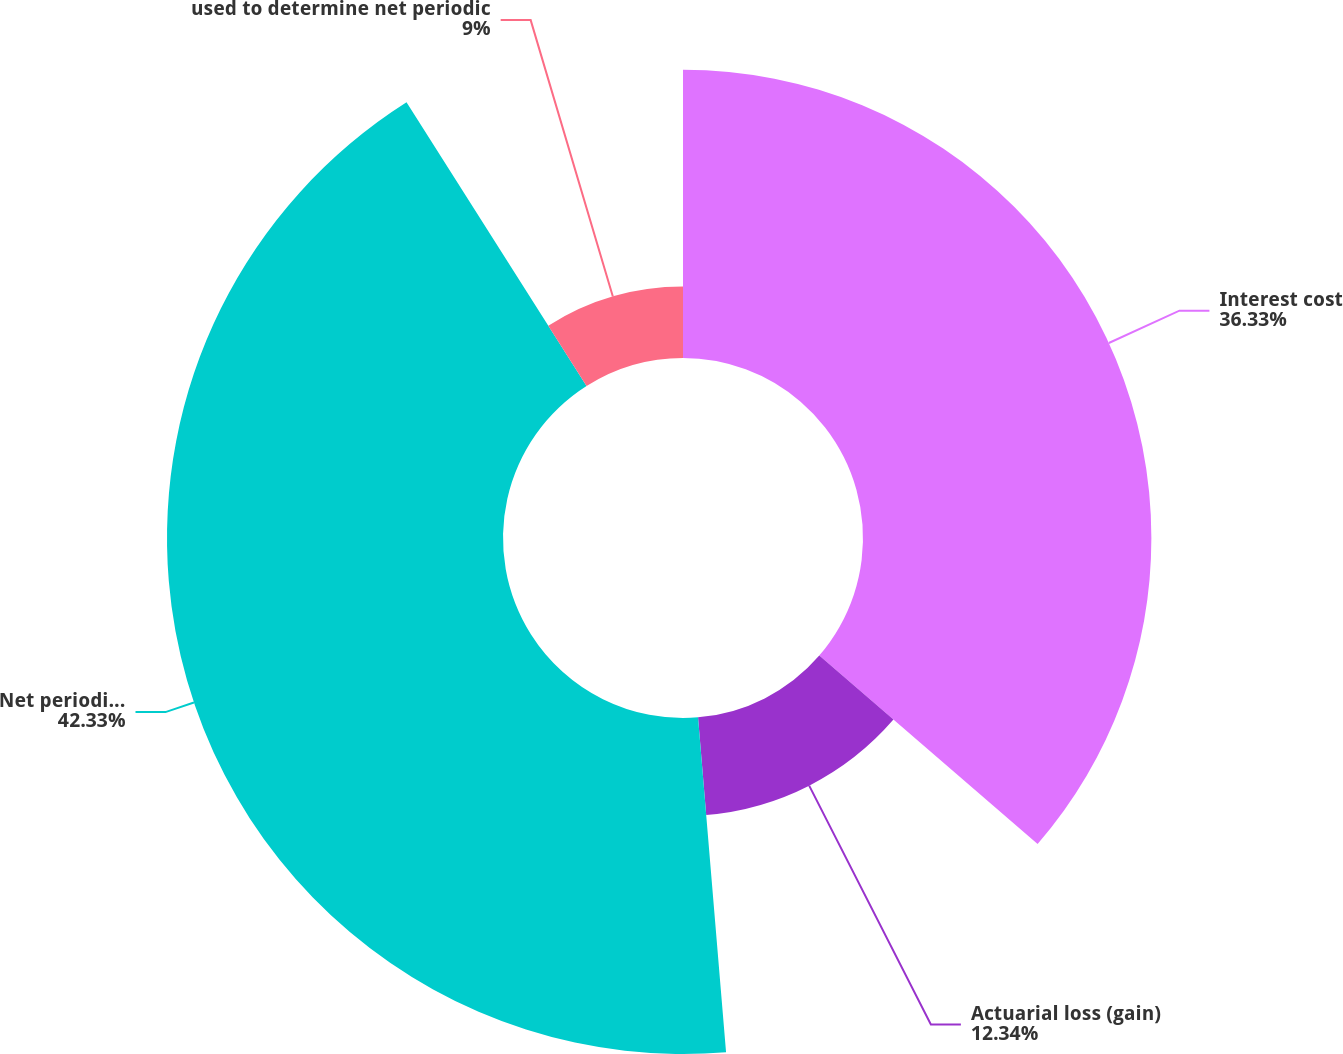Convert chart to OTSL. <chart><loc_0><loc_0><loc_500><loc_500><pie_chart><fcel>Interest cost<fcel>Actuarial loss (gain)<fcel>Net periodic benefit cost<fcel>used to determine net periodic<nl><fcel>36.33%<fcel>12.34%<fcel>42.33%<fcel>9.0%<nl></chart> 